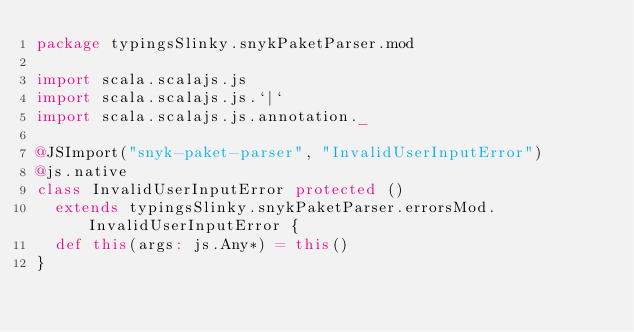<code> <loc_0><loc_0><loc_500><loc_500><_Scala_>package typingsSlinky.snykPaketParser.mod

import scala.scalajs.js
import scala.scalajs.js.`|`
import scala.scalajs.js.annotation._

@JSImport("snyk-paket-parser", "InvalidUserInputError")
@js.native
class InvalidUserInputError protected ()
  extends typingsSlinky.snykPaketParser.errorsMod.InvalidUserInputError {
  def this(args: js.Any*) = this()
}

</code> 